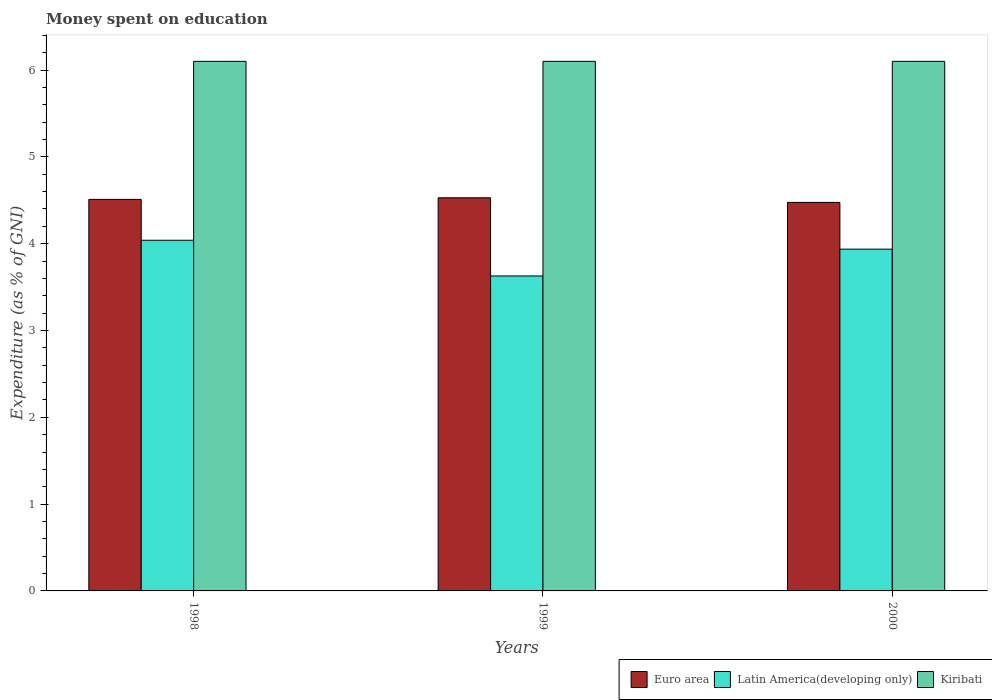How many different coloured bars are there?
Ensure brevity in your answer.  3. Are the number of bars per tick equal to the number of legend labels?
Make the answer very short. Yes. How many bars are there on the 2nd tick from the left?
Give a very brief answer. 3. How many bars are there on the 2nd tick from the right?
Give a very brief answer. 3. In how many cases, is the number of bars for a given year not equal to the number of legend labels?
Your answer should be compact. 0. What is the amount of money spent on education in Latin America(developing only) in 1998?
Make the answer very short. 4.04. Across all years, what is the maximum amount of money spent on education in Kiribati?
Provide a succinct answer. 6.1. Across all years, what is the minimum amount of money spent on education in Euro area?
Offer a very short reply. 4.48. What is the total amount of money spent on education in Latin America(developing only) in the graph?
Offer a terse response. 11.6. What is the difference between the amount of money spent on education in Euro area in 2000 and the amount of money spent on education in Kiribati in 1999?
Your answer should be very brief. -1.62. What is the average amount of money spent on education in Latin America(developing only) per year?
Ensure brevity in your answer.  3.87. In the year 2000, what is the difference between the amount of money spent on education in Kiribati and amount of money spent on education in Latin America(developing only)?
Provide a succinct answer. 2.16. What is the ratio of the amount of money spent on education in Latin America(developing only) in 1998 to that in 1999?
Your answer should be very brief. 1.11. Is the difference between the amount of money spent on education in Kiribati in 1998 and 1999 greater than the difference between the amount of money spent on education in Latin America(developing only) in 1998 and 1999?
Keep it short and to the point. No. What is the difference between the highest and the second highest amount of money spent on education in Kiribati?
Provide a short and direct response. 0. What is the difference between the highest and the lowest amount of money spent on education in Kiribati?
Your response must be concise. 0. Is the sum of the amount of money spent on education in Kiribati in 1998 and 1999 greater than the maximum amount of money spent on education in Latin America(developing only) across all years?
Provide a short and direct response. Yes. What does the 2nd bar from the right in 2000 represents?
Give a very brief answer. Latin America(developing only). Is it the case that in every year, the sum of the amount of money spent on education in Kiribati and amount of money spent on education in Latin America(developing only) is greater than the amount of money spent on education in Euro area?
Ensure brevity in your answer.  Yes. How many bars are there?
Keep it short and to the point. 9. Are all the bars in the graph horizontal?
Provide a succinct answer. No. What is the difference between two consecutive major ticks on the Y-axis?
Your response must be concise. 1. Are the values on the major ticks of Y-axis written in scientific E-notation?
Keep it short and to the point. No. Does the graph contain any zero values?
Offer a terse response. No. Does the graph contain grids?
Make the answer very short. No. Where does the legend appear in the graph?
Provide a succinct answer. Bottom right. How many legend labels are there?
Your answer should be very brief. 3. What is the title of the graph?
Offer a very short reply. Money spent on education. What is the label or title of the Y-axis?
Make the answer very short. Expenditure (as % of GNI). What is the Expenditure (as % of GNI) of Euro area in 1998?
Offer a very short reply. 4.51. What is the Expenditure (as % of GNI) in Latin America(developing only) in 1998?
Your answer should be very brief. 4.04. What is the Expenditure (as % of GNI) of Euro area in 1999?
Your answer should be very brief. 4.53. What is the Expenditure (as % of GNI) of Latin America(developing only) in 1999?
Provide a succinct answer. 3.63. What is the Expenditure (as % of GNI) in Kiribati in 1999?
Make the answer very short. 6.1. What is the Expenditure (as % of GNI) in Euro area in 2000?
Make the answer very short. 4.48. What is the Expenditure (as % of GNI) of Latin America(developing only) in 2000?
Your answer should be very brief. 3.94. What is the Expenditure (as % of GNI) in Kiribati in 2000?
Your answer should be compact. 6.1. Across all years, what is the maximum Expenditure (as % of GNI) of Euro area?
Provide a succinct answer. 4.53. Across all years, what is the maximum Expenditure (as % of GNI) in Latin America(developing only)?
Provide a short and direct response. 4.04. Across all years, what is the maximum Expenditure (as % of GNI) in Kiribati?
Provide a succinct answer. 6.1. Across all years, what is the minimum Expenditure (as % of GNI) of Euro area?
Your answer should be compact. 4.48. Across all years, what is the minimum Expenditure (as % of GNI) in Latin America(developing only)?
Give a very brief answer. 3.63. Across all years, what is the minimum Expenditure (as % of GNI) in Kiribati?
Make the answer very short. 6.1. What is the total Expenditure (as % of GNI) in Euro area in the graph?
Make the answer very short. 13.51. What is the total Expenditure (as % of GNI) of Latin America(developing only) in the graph?
Offer a terse response. 11.6. What is the difference between the Expenditure (as % of GNI) of Euro area in 1998 and that in 1999?
Provide a succinct answer. -0.02. What is the difference between the Expenditure (as % of GNI) in Latin America(developing only) in 1998 and that in 1999?
Your answer should be compact. 0.41. What is the difference between the Expenditure (as % of GNI) of Euro area in 1998 and that in 2000?
Make the answer very short. 0.04. What is the difference between the Expenditure (as % of GNI) in Latin America(developing only) in 1998 and that in 2000?
Provide a short and direct response. 0.1. What is the difference between the Expenditure (as % of GNI) in Euro area in 1999 and that in 2000?
Ensure brevity in your answer.  0.05. What is the difference between the Expenditure (as % of GNI) of Latin America(developing only) in 1999 and that in 2000?
Your answer should be compact. -0.31. What is the difference between the Expenditure (as % of GNI) in Euro area in 1998 and the Expenditure (as % of GNI) in Latin America(developing only) in 1999?
Your answer should be compact. 0.88. What is the difference between the Expenditure (as % of GNI) in Euro area in 1998 and the Expenditure (as % of GNI) in Kiribati in 1999?
Your response must be concise. -1.59. What is the difference between the Expenditure (as % of GNI) of Latin America(developing only) in 1998 and the Expenditure (as % of GNI) of Kiribati in 1999?
Your response must be concise. -2.06. What is the difference between the Expenditure (as % of GNI) of Euro area in 1998 and the Expenditure (as % of GNI) of Latin America(developing only) in 2000?
Make the answer very short. 0.57. What is the difference between the Expenditure (as % of GNI) of Euro area in 1998 and the Expenditure (as % of GNI) of Kiribati in 2000?
Your response must be concise. -1.59. What is the difference between the Expenditure (as % of GNI) of Latin America(developing only) in 1998 and the Expenditure (as % of GNI) of Kiribati in 2000?
Ensure brevity in your answer.  -2.06. What is the difference between the Expenditure (as % of GNI) in Euro area in 1999 and the Expenditure (as % of GNI) in Latin America(developing only) in 2000?
Offer a very short reply. 0.59. What is the difference between the Expenditure (as % of GNI) of Euro area in 1999 and the Expenditure (as % of GNI) of Kiribati in 2000?
Ensure brevity in your answer.  -1.57. What is the difference between the Expenditure (as % of GNI) in Latin America(developing only) in 1999 and the Expenditure (as % of GNI) in Kiribati in 2000?
Make the answer very short. -2.47. What is the average Expenditure (as % of GNI) in Euro area per year?
Give a very brief answer. 4.5. What is the average Expenditure (as % of GNI) in Latin America(developing only) per year?
Offer a very short reply. 3.87. In the year 1998, what is the difference between the Expenditure (as % of GNI) of Euro area and Expenditure (as % of GNI) of Latin America(developing only)?
Make the answer very short. 0.47. In the year 1998, what is the difference between the Expenditure (as % of GNI) of Euro area and Expenditure (as % of GNI) of Kiribati?
Make the answer very short. -1.59. In the year 1998, what is the difference between the Expenditure (as % of GNI) in Latin America(developing only) and Expenditure (as % of GNI) in Kiribati?
Make the answer very short. -2.06. In the year 1999, what is the difference between the Expenditure (as % of GNI) of Euro area and Expenditure (as % of GNI) of Latin America(developing only)?
Ensure brevity in your answer.  0.9. In the year 1999, what is the difference between the Expenditure (as % of GNI) of Euro area and Expenditure (as % of GNI) of Kiribati?
Offer a terse response. -1.57. In the year 1999, what is the difference between the Expenditure (as % of GNI) of Latin America(developing only) and Expenditure (as % of GNI) of Kiribati?
Offer a very short reply. -2.47. In the year 2000, what is the difference between the Expenditure (as % of GNI) of Euro area and Expenditure (as % of GNI) of Latin America(developing only)?
Provide a short and direct response. 0.54. In the year 2000, what is the difference between the Expenditure (as % of GNI) of Euro area and Expenditure (as % of GNI) of Kiribati?
Provide a short and direct response. -1.62. In the year 2000, what is the difference between the Expenditure (as % of GNI) of Latin America(developing only) and Expenditure (as % of GNI) of Kiribati?
Offer a terse response. -2.16. What is the ratio of the Expenditure (as % of GNI) in Latin America(developing only) in 1998 to that in 1999?
Provide a succinct answer. 1.11. What is the ratio of the Expenditure (as % of GNI) in Euro area in 1998 to that in 2000?
Provide a short and direct response. 1.01. What is the ratio of the Expenditure (as % of GNI) of Latin America(developing only) in 1998 to that in 2000?
Offer a very short reply. 1.03. What is the ratio of the Expenditure (as % of GNI) of Euro area in 1999 to that in 2000?
Offer a very short reply. 1.01. What is the ratio of the Expenditure (as % of GNI) in Latin America(developing only) in 1999 to that in 2000?
Provide a succinct answer. 0.92. What is the ratio of the Expenditure (as % of GNI) in Kiribati in 1999 to that in 2000?
Provide a short and direct response. 1. What is the difference between the highest and the second highest Expenditure (as % of GNI) in Euro area?
Your answer should be compact. 0.02. What is the difference between the highest and the second highest Expenditure (as % of GNI) in Latin America(developing only)?
Provide a short and direct response. 0.1. What is the difference between the highest and the lowest Expenditure (as % of GNI) in Euro area?
Provide a short and direct response. 0.05. What is the difference between the highest and the lowest Expenditure (as % of GNI) of Latin America(developing only)?
Provide a short and direct response. 0.41. 